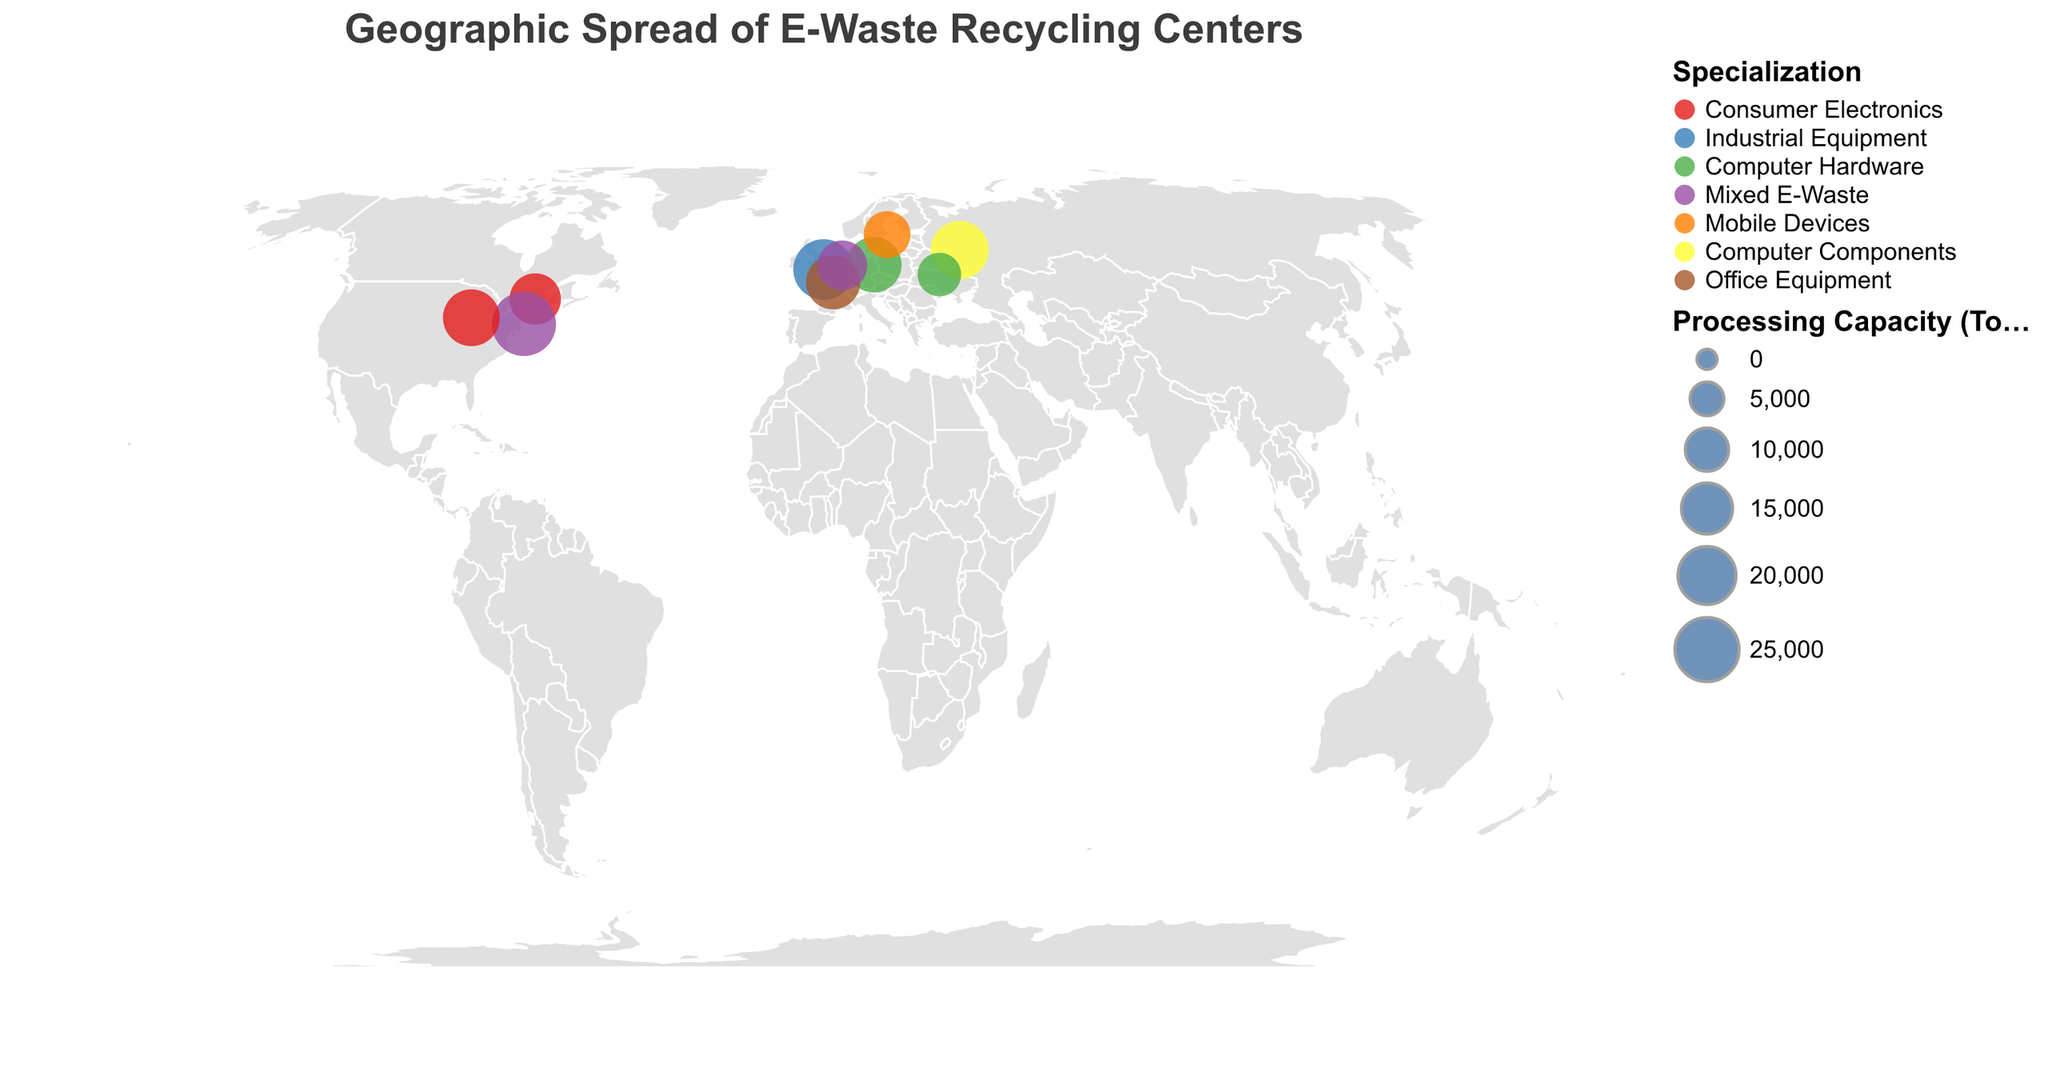Which city has the highest e-waste processing capacity in the USA? Refer to the circles on the USA map, compare their sizes and hover over them to see the details. Among the cities, New York with NYC Tech Recycle has the highest processing capacity of 25000 tons/year.
Answer: New York What is the total e-waste processing capacity of the recycling centers specializing in Computer Hardware? Identify all centers specializing in Computer Hardware using their tooltip information. Berlin and Kyiv specialize in Computer Hardware, with capacities of 18000 and 10000 tons/year respectively. Sum them up: 18000 + 10000 = 28000 tons/year.
Answer: 28000 tons/year Which city in Europe specializes in Industrial Equipment e-waste recycling? Look for the circle color corresponding to Industrial Equipment specialization in Europe using the legend. According to the tooltip, London specializes in Industrial Equipment.
Answer: London Compare the processing capacities of Montreal and Chicago. Which city has the higher capacity? Explore the map to find Montreal and Chicago, and hover over their circles to check their capacities. Montreal has 15000 tons/year and Chicago has 19000 tons/year. Chicago has the higher capacity.
Answer: Chicago Identify the city with the smallest e-waste processing capacity and state its specialization. Compare the sizes of all circles and hover over the smallest one to get its details. The smallest circle is Kyiv, with a capacity of 10000 tons/year, specializing in Computer Hardware.
Answer: Kyiv, Computer Hardware How many recycling centers specialize in Mixed E-Waste in North America and Europe combined? Use the legend to find the color representing Mixed E-Waste specialization and count the corresponding circles in North America and Europe. There are two centers: NYC Tech Recycle in New York and Dutch E-Cycle Solutions in Amsterdam.
Answer: 2 centers Which country has multiple e-waste recycling centers represented on the map? Scan the tooltip information to check the countries of each center. The USA has two centers: NYC Tech Recycle in New York and Midwest Electronics Recovery in Chicago.
Answer: USA What is the average processing capacity of all e-waste recycling centers shown? Add the capacities of all centers: 15000 + 22000 + 18000 + 25000 + 12000 + 20000 + 17000 + 19000 + 10000 + 14000 = 172000 tons/year. There are 10 centers, so the average is 172000 / 10 = 17200 tons/year.
Answer: 17200 tons/year Which city in North America has the highest processing capacity for Consumer Electronics? Identify the circles in North America specializing in Consumer Electronics and compare their sizes. Chicago's Midwest Electronics Recovery has the highest capacity at 19000 tons/year.
Answer: Chicago What is the processing capacity difference between the centers in Montreal and Moscow? Hover over the circles for Montreal and Moscow to see their capacities. Montreal has 15000 tons/year and Moscow has 20000 tons/year. The difference is 20000 - 15000 = 5000 tons/year.
Answer: 5000 tons/year 